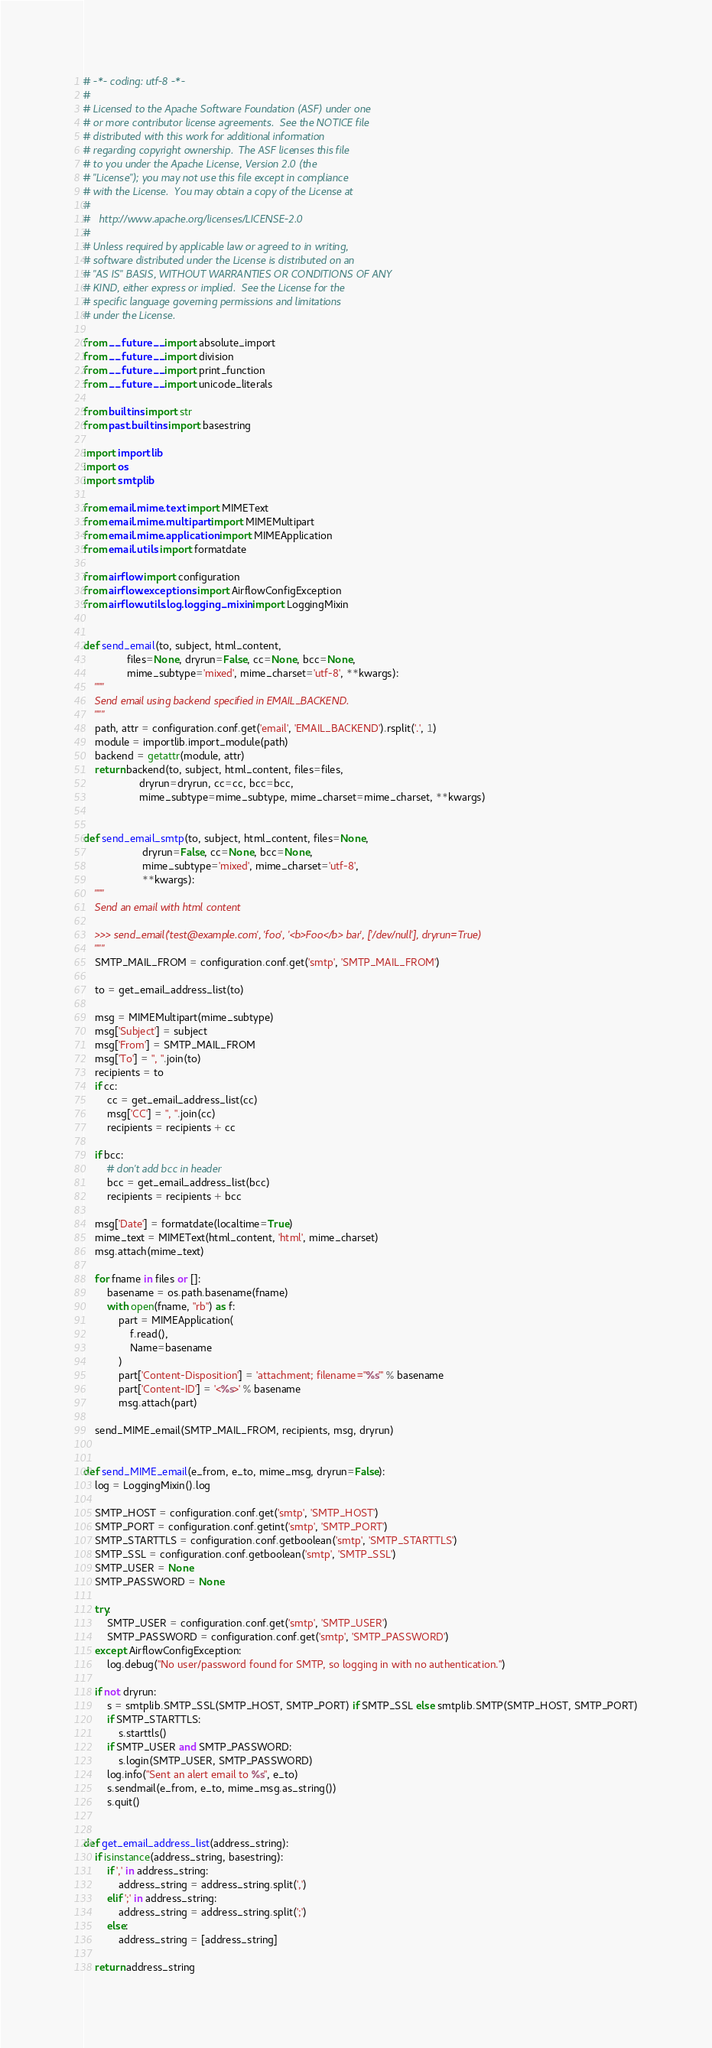Convert code to text. <code><loc_0><loc_0><loc_500><loc_500><_Python_># -*- coding: utf-8 -*-
#
# Licensed to the Apache Software Foundation (ASF) under one
# or more contributor license agreements.  See the NOTICE file
# distributed with this work for additional information
# regarding copyright ownership.  The ASF licenses this file
# to you under the Apache License, Version 2.0 (the
# "License"); you may not use this file except in compliance
# with the License.  You may obtain a copy of the License at
#
#   http://www.apache.org/licenses/LICENSE-2.0
#
# Unless required by applicable law or agreed to in writing,
# software distributed under the License is distributed on an
# "AS IS" BASIS, WITHOUT WARRANTIES OR CONDITIONS OF ANY
# KIND, either express or implied.  See the License for the
# specific language governing permissions and limitations
# under the License.

from __future__ import absolute_import
from __future__ import division
from __future__ import print_function
from __future__ import unicode_literals

from builtins import str
from past.builtins import basestring

import importlib
import os
import smtplib

from email.mime.text import MIMEText
from email.mime.multipart import MIMEMultipart
from email.mime.application import MIMEApplication
from email.utils import formatdate

from airflow import configuration
from airflow.exceptions import AirflowConfigException
from airflow.utils.log.logging_mixin import LoggingMixin


def send_email(to, subject, html_content,
               files=None, dryrun=False, cc=None, bcc=None,
               mime_subtype='mixed', mime_charset='utf-8', **kwargs):
    """
    Send email using backend specified in EMAIL_BACKEND.
    """
    path, attr = configuration.conf.get('email', 'EMAIL_BACKEND').rsplit('.', 1)
    module = importlib.import_module(path)
    backend = getattr(module, attr)
    return backend(to, subject, html_content, files=files,
                   dryrun=dryrun, cc=cc, bcc=bcc,
                   mime_subtype=mime_subtype, mime_charset=mime_charset, **kwargs)


def send_email_smtp(to, subject, html_content, files=None,
                    dryrun=False, cc=None, bcc=None,
                    mime_subtype='mixed', mime_charset='utf-8',
                    **kwargs):
    """
    Send an email with html content

    >>> send_email('test@example.com', 'foo', '<b>Foo</b> bar', ['/dev/null'], dryrun=True)
    """
    SMTP_MAIL_FROM = configuration.conf.get('smtp', 'SMTP_MAIL_FROM')

    to = get_email_address_list(to)

    msg = MIMEMultipart(mime_subtype)
    msg['Subject'] = subject
    msg['From'] = SMTP_MAIL_FROM
    msg['To'] = ", ".join(to)
    recipients = to
    if cc:
        cc = get_email_address_list(cc)
        msg['CC'] = ", ".join(cc)
        recipients = recipients + cc

    if bcc:
        # don't add bcc in header
        bcc = get_email_address_list(bcc)
        recipients = recipients + bcc

    msg['Date'] = formatdate(localtime=True)
    mime_text = MIMEText(html_content, 'html', mime_charset)
    msg.attach(mime_text)

    for fname in files or []:
        basename = os.path.basename(fname)
        with open(fname, "rb") as f:
            part = MIMEApplication(
                f.read(),
                Name=basename
            )
            part['Content-Disposition'] = 'attachment; filename="%s"' % basename
            part['Content-ID'] = '<%s>' % basename
            msg.attach(part)

    send_MIME_email(SMTP_MAIL_FROM, recipients, msg, dryrun)


def send_MIME_email(e_from, e_to, mime_msg, dryrun=False):
    log = LoggingMixin().log

    SMTP_HOST = configuration.conf.get('smtp', 'SMTP_HOST')
    SMTP_PORT = configuration.conf.getint('smtp', 'SMTP_PORT')
    SMTP_STARTTLS = configuration.conf.getboolean('smtp', 'SMTP_STARTTLS')
    SMTP_SSL = configuration.conf.getboolean('smtp', 'SMTP_SSL')
    SMTP_USER = None
    SMTP_PASSWORD = None

    try:
        SMTP_USER = configuration.conf.get('smtp', 'SMTP_USER')
        SMTP_PASSWORD = configuration.conf.get('smtp', 'SMTP_PASSWORD')
    except AirflowConfigException:
        log.debug("No user/password found for SMTP, so logging in with no authentication.")

    if not dryrun:
        s = smtplib.SMTP_SSL(SMTP_HOST, SMTP_PORT) if SMTP_SSL else smtplib.SMTP(SMTP_HOST, SMTP_PORT)
        if SMTP_STARTTLS:
            s.starttls()
        if SMTP_USER and SMTP_PASSWORD:
            s.login(SMTP_USER, SMTP_PASSWORD)
        log.info("Sent an alert email to %s", e_to)
        s.sendmail(e_from, e_to, mime_msg.as_string())
        s.quit()


def get_email_address_list(address_string):
    if isinstance(address_string, basestring):
        if ',' in address_string:
            address_string = address_string.split(',')
        elif ';' in address_string:
            address_string = address_string.split(';')
        else:
            address_string = [address_string]

    return address_string
</code> 